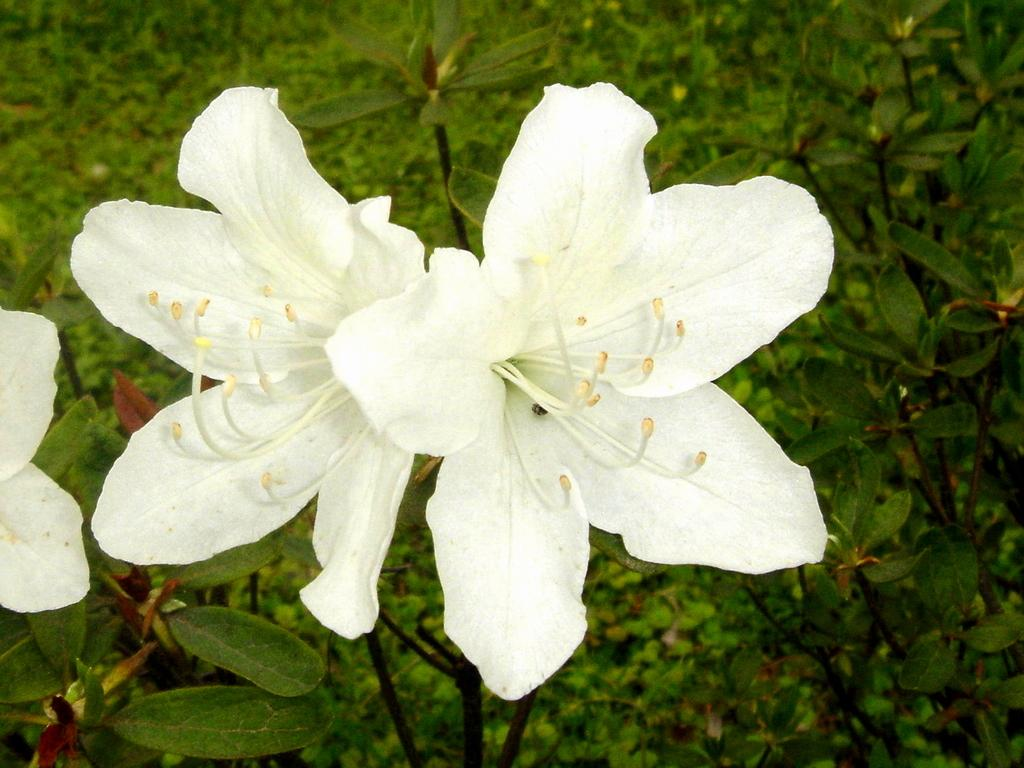What type of living organisms can be seen in the image? Flowers and plants are visible in the image. Can you describe the background of the image? The background of the image includes many plants. What type of memory can be seen in the image? There is no memory present in the image; it features flowers and plants. What type of attraction can be seen in the image? There is no attraction present in the image; it features flowers and plants. 